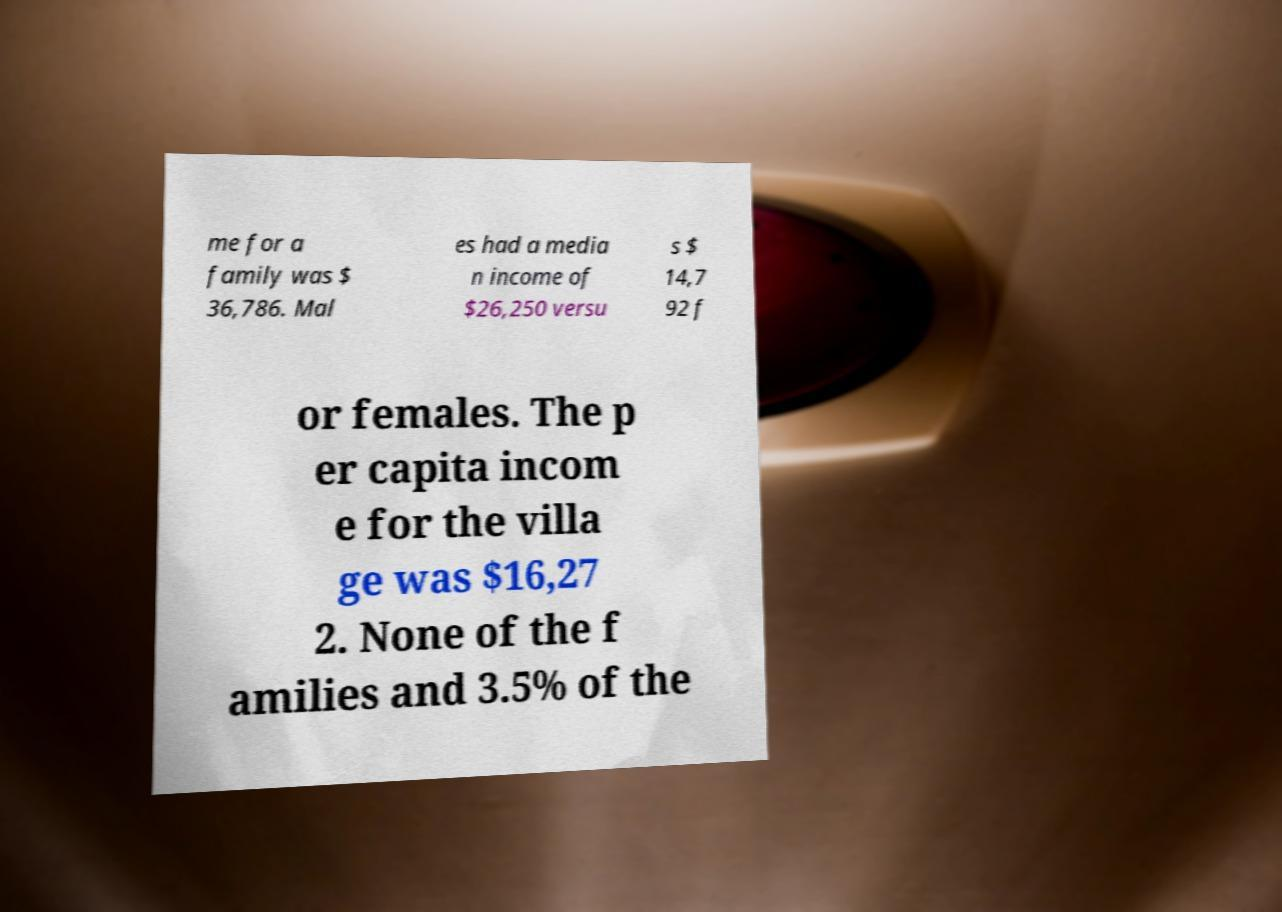Can you read and provide the text displayed in the image?This photo seems to have some interesting text. Can you extract and type it out for me? me for a family was $ 36,786. Mal es had a media n income of $26,250 versu s $ 14,7 92 f or females. The p er capita incom e for the villa ge was $16,27 2. None of the f amilies and 3.5% of the 